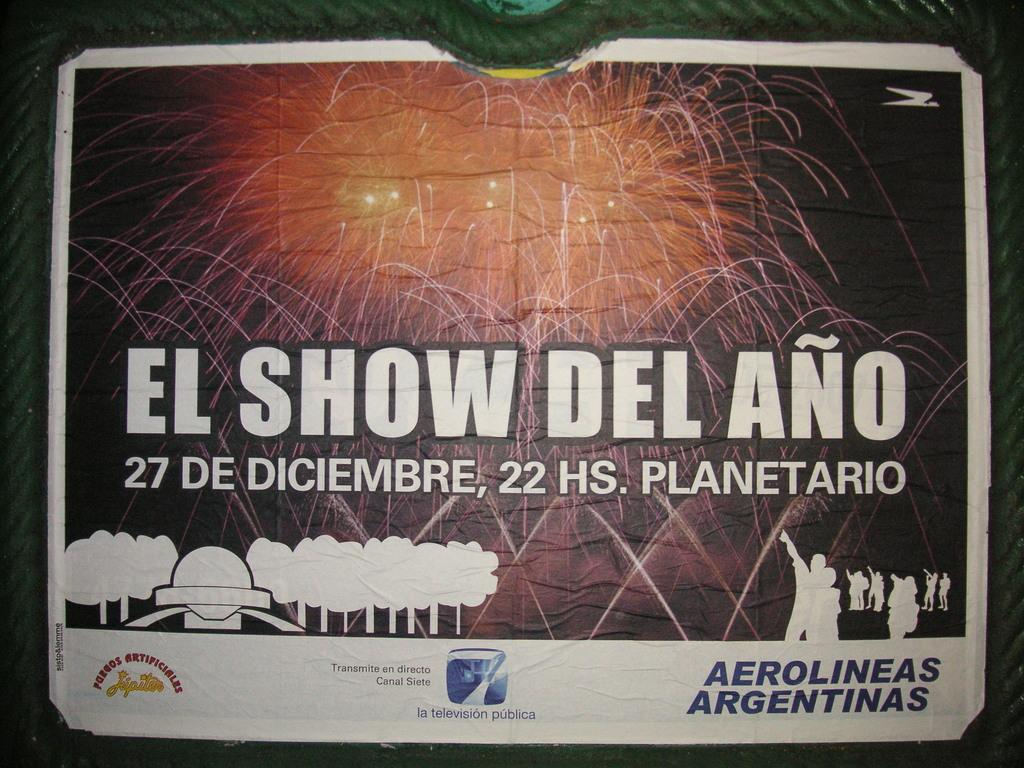Provide a one-sentence caption for the provided image. El show del ano takes place in diciembre which is spanish. 